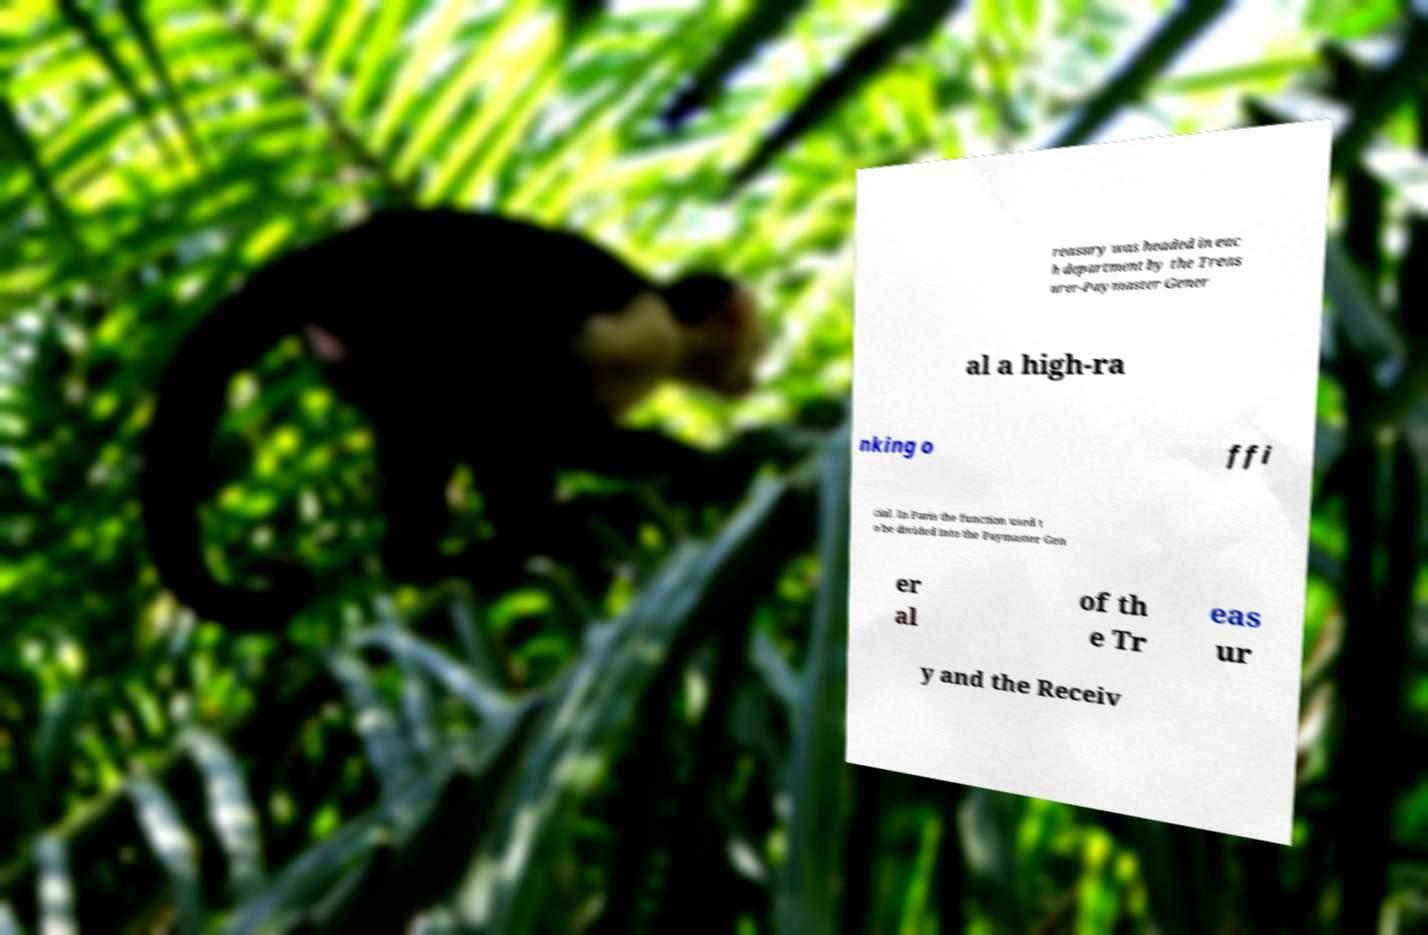I need the written content from this picture converted into text. Can you do that? reasury was headed in eac h department by the Treas urer-Paymaster Gener al a high-ra nking o ffi cial. In Paris the function used t o be divided into the Paymaster Gen er al of th e Tr eas ur y and the Receiv 